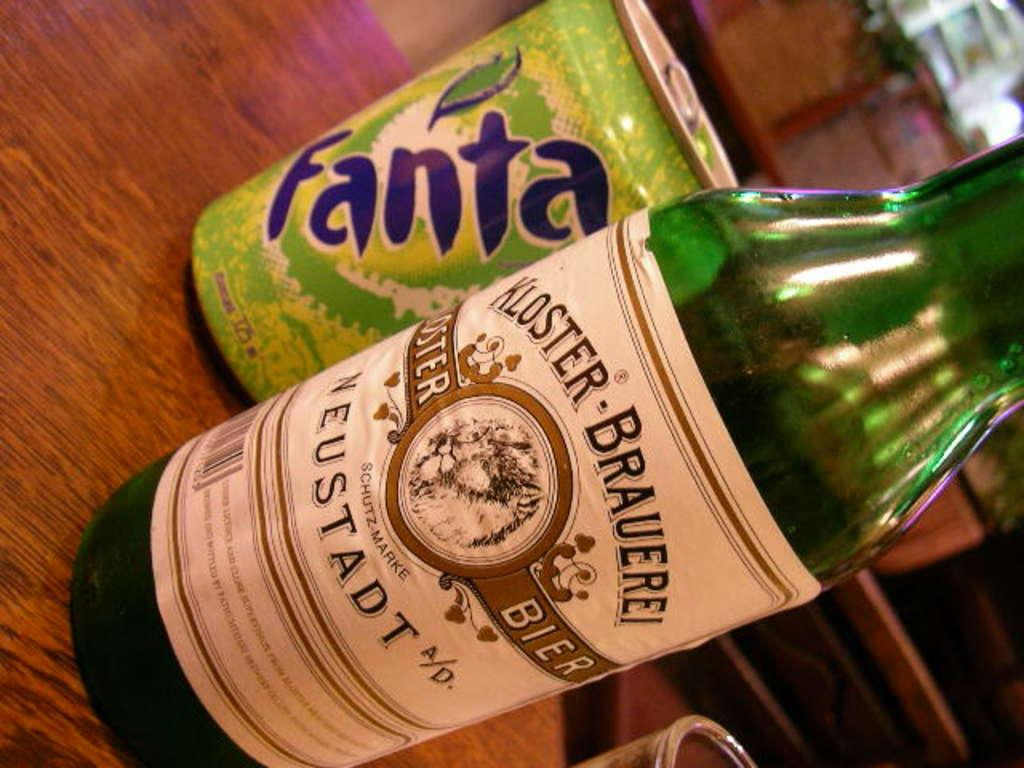<image>
Create a compact narrative representing the image presented. a can of fanta next to a bottle of kloster brauerei 